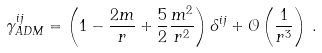<formula> <loc_0><loc_0><loc_500><loc_500>\gamma ^ { i j } _ { A D M } = \left ( 1 - \frac { 2 m } { r } + \frac { 5 } { 2 } \frac { m ^ { 2 } } { r ^ { 2 } } \right ) \delta ^ { i j } + \mathcal { O } \left ( \frac { 1 } { r ^ { 3 } } \right ) \, .</formula> 